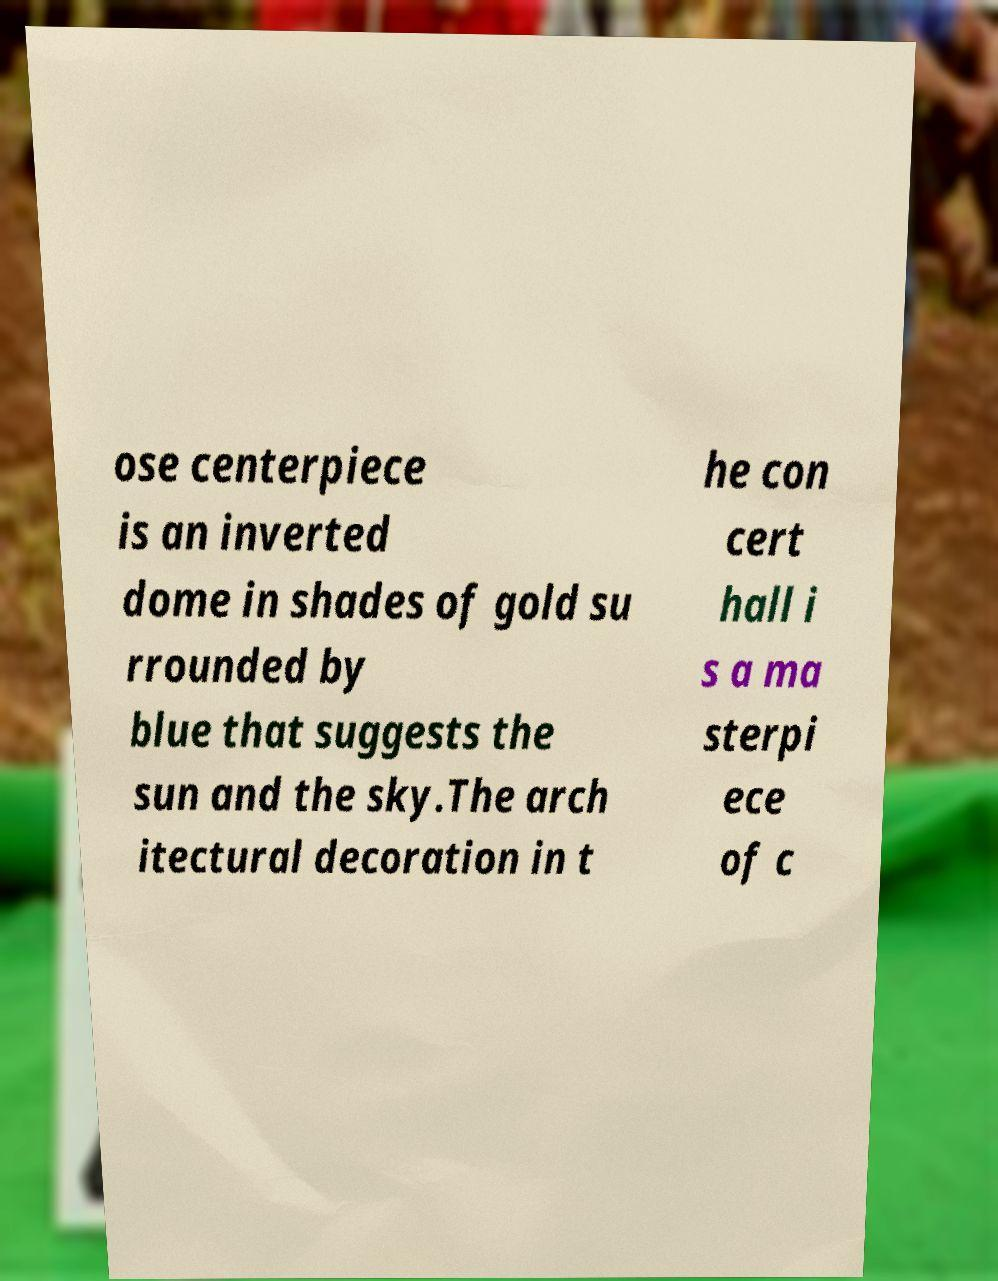Please identify and transcribe the text found in this image. ose centerpiece is an inverted dome in shades of gold su rrounded by blue that suggests the sun and the sky.The arch itectural decoration in t he con cert hall i s a ma sterpi ece of c 